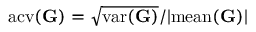Convert formula to latex. <formula><loc_0><loc_0><loc_500><loc_500>a c v ( \mathbf G ) = \sqrt { v a r ( \mathbf G ) } / | m e a n ( \mathbf G ) |</formula> 